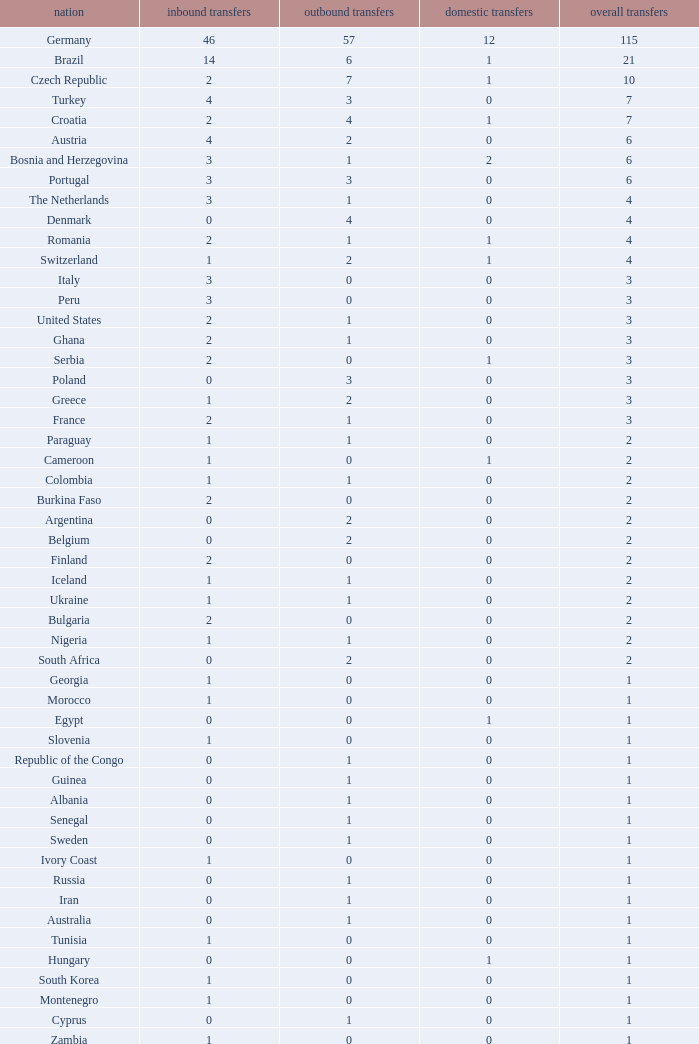What are the Transfers out for Peru? 0.0. 